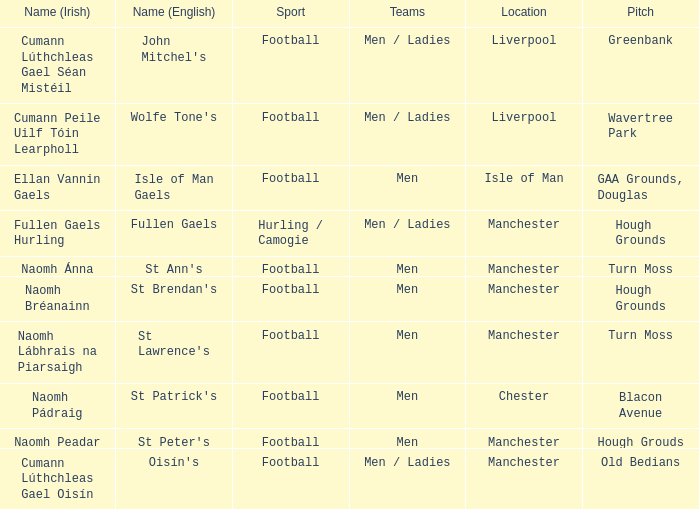Parse the table in full. {'header': ['Name (Irish)', 'Name (English)', 'Sport', 'Teams', 'Location', 'Pitch'], 'rows': [['Cumann Lúthchleas Gael Séan Mistéil', "John Mitchel's", 'Football', 'Men / Ladies', 'Liverpool', 'Greenbank'], ['Cumann Peile Uilf Tóin Learpholl', "Wolfe Tone's", 'Football', 'Men / Ladies', 'Liverpool', 'Wavertree Park'], ['Ellan Vannin Gaels', 'Isle of Man Gaels', 'Football', 'Men', 'Isle of Man', 'GAA Grounds, Douglas'], ['Fullen Gaels Hurling', 'Fullen Gaels', 'Hurling / Camogie', 'Men / Ladies', 'Manchester', 'Hough Grounds'], ['Naomh Ánna', "St Ann's", 'Football', 'Men', 'Manchester', 'Turn Moss'], ['Naomh Bréanainn', "St Brendan's", 'Football', 'Men', 'Manchester', 'Hough Grounds'], ['Naomh Lábhrais na Piarsaigh', "St Lawrence's", 'Football', 'Men', 'Manchester', 'Turn Moss'], ['Naomh Pádraig', "St Patrick's", 'Football', 'Men', 'Chester', 'Blacon Avenue'], ['Naomh Peadar', "St Peter's", 'Football', 'Men', 'Manchester', 'Hough Grouds'], ['Cumann Lúthchleas Gael Oisín', "Oisín's", 'Football', 'Men / Ladies', 'Manchester', 'Old Bedians']]} What is the site of the old bedians pitch? Manchester. 